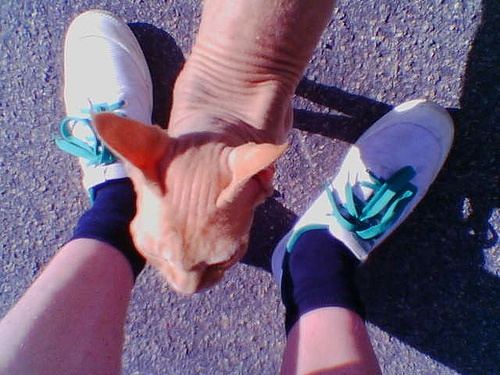Describe the objects in this image and their specific colors. I can see people in gray, lightgray, blue, black, and navy tones and cat in gray, lightpink, maroon, and brown tones in this image. 